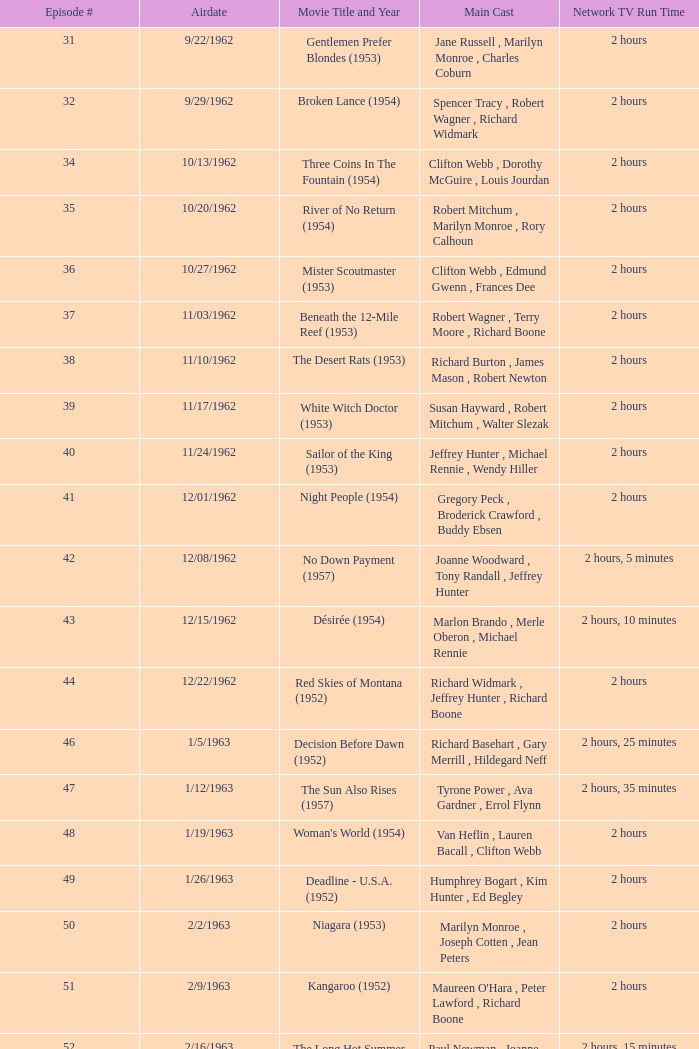Who comprised the cast in the episode on 3/23/1963? Dana Wynter , Mel Ferrer , Theodore Bikel. 